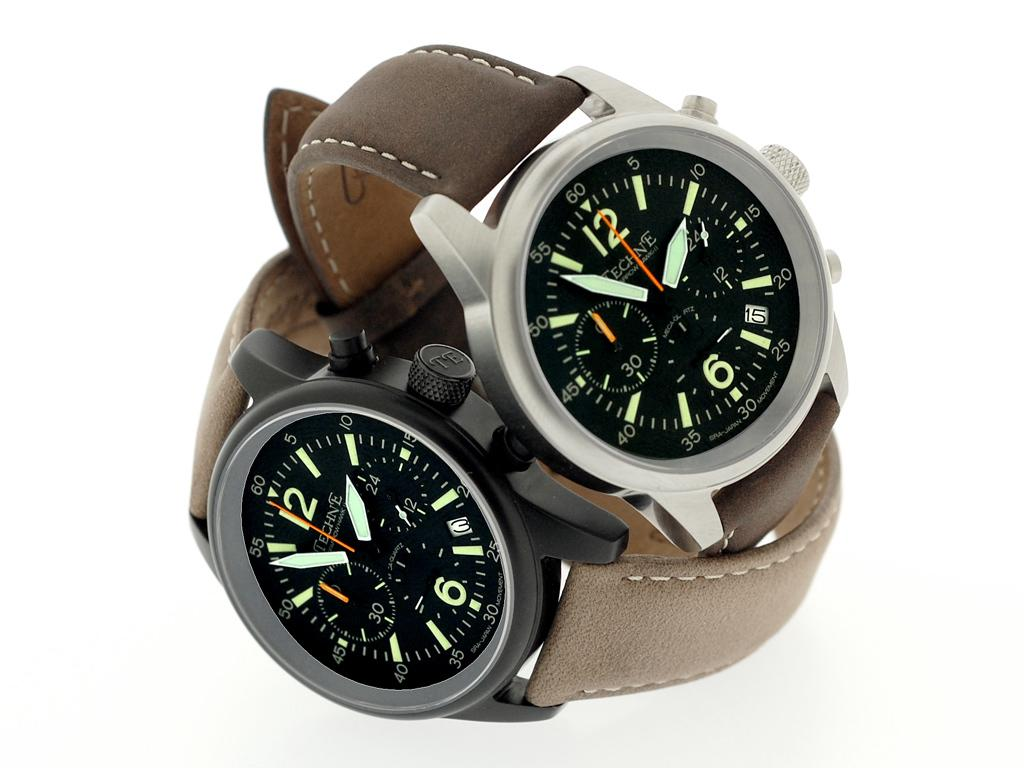<image>
Describe the image concisely. Two Techne watches are on top of each other. 